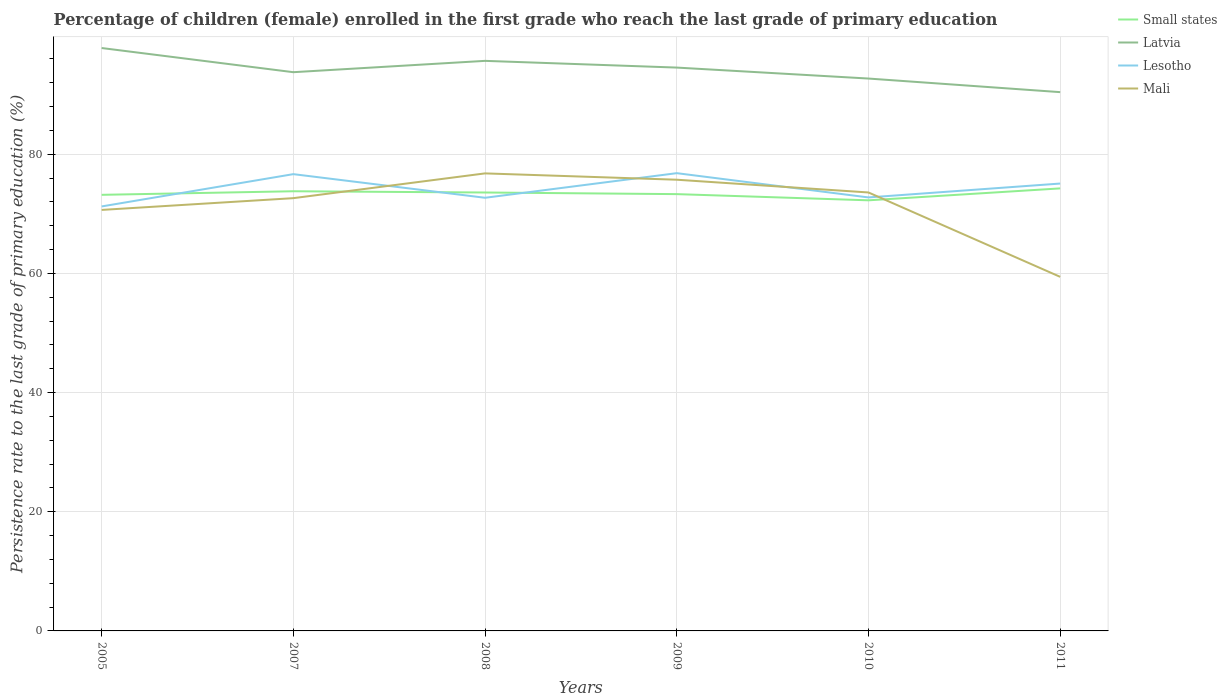Is the number of lines equal to the number of legend labels?
Provide a short and direct response. Yes. Across all years, what is the maximum persistence rate of children in Lesotho?
Provide a succinct answer. 71.23. In which year was the persistence rate of children in Latvia maximum?
Your answer should be compact. 2011. What is the total persistence rate of children in Small states in the graph?
Ensure brevity in your answer.  0.21. What is the difference between the highest and the second highest persistence rate of children in Lesotho?
Offer a very short reply. 5.58. How many years are there in the graph?
Offer a terse response. 6. Does the graph contain grids?
Offer a terse response. Yes. Where does the legend appear in the graph?
Offer a terse response. Top right. How many legend labels are there?
Your answer should be very brief. 4. What is the title of the graph?
Keep it short and to the point. Percentage of children (female) enrolled in the first grade who reach the last grade of primary education. Does "Europe(developing only)" appear as one of the legend labels in the graph?
Your response must be concise. No. What is the label or title of the Y-axis?
Your response must be concise. Persistence rate to the last grade of primary education (%). What is the Persistence rate to the last grade of primary education (%) of Small states in 2005?
Offer a very short reply. 73.18. What is the Persistence rate to the last grade of primary education (%) of Latvia in 2005?
Offer a terse response. 97.82. What is the Persistence rate to the last grade of primary education (%) of Lesotho in 2005?
Your response must be concise. 71.23. What is the Persistence rate to the last grade of primary education (%) of Mali in 2005?
Your answer should be compact. 70.65. What is the Persistence rate to the last grade of primary education (%) of Small states in 2007?
Your answer should be compact. 73.78. What is the Persistence rate to the last grade of primary education (%) of Latvia in 2007?
Your answer should be compact. 93.76. What is the Persistence rate to the last grade of primary education (%) of Lesotho in 2007?
Your answer should be compact. 76.65. What is the Persistence rate to the last grade of primary education (%) in Mali in 2007?
Offer a terse response. 72.62. What is the Persistence rate to the last grade of primary education (%) of Small states in 2008?
Your answer should be very brief. 73.57. What is the Persistence rate to the last grade of primary education (%) in Latvia in 2008?
Offer a very short reply. 95.66. What is the Persistence rate to the last grade of primary education (%) in Lesotho in 2008?
Your response must be concise. 72.69. What is the Persistence rate to the last grade of primary education (%) of Mali in 2008?
Your response must be concise. 76.78. What is the Persistence rate to the last grade of primary education (%) of Small states in 2009?
Your answer should be compact. 73.3. What is the Persistence rate to the last grade of primary education (%) of Latvia in 2009?
Make the answer very short. 94.54. What is the Persistence rate to the last grade of primary education (%) of Lesotho in 2009?
Give a very brief answer. 76.82. What is the Persistence rate to the last grade of primary education (%) of Mali in 2009?
Offer a very short reply. 75.72. What is the Persistence rate to the last grade of primary education (%) of Small states in 2010?
Offer a terse response. 72.26. What is the Persistence rate to the last grade of primary education (%) of Latvia in 2010?
Make the answer very short. 92.7. What is the Persistence rate to the last grade of primary education (%) of Lesotho in 2010?
Offer a terse response. 72.75. What is the Persistence rate to the last grade of primary education (%) of Mali in 2010?
Your answer should be very brief. 73.58. What is the Persistence rate to the last grade of primary education (%) of Small states in 2011?
Give a very brief answer. 74.26. What is the Persistence rate to the last grade of primary education (%) in Latvia in 2011?
Offer a terse response. 90.41. What is the Persistence rate to the last grade of primary education (%) of Lesotho in 2011?
Provide a short and direct response. 75.07. What is the Persistence rate to the last grade of primary education (%) in Mali in 2011?
Provide a short and direct response. 59.42. Across all years, what is the maximum Persistence rate to the last grade of primary education (%) of Small states?
Offer a very short reply. 74.26. Across all years, what is the maximum Persistence rate to the last grade of primary education (%) in Latvia?
Your response must be concise. 97.82. Across all years, what is the maximum Persistence rate to the last grade of primary education (%) in Lesotho?
Ensure brevity in your answer.  76.82. Across all years, what is the maximum Persistence rate to the last grade of primary education (%) in Mali?
Your answer should be compact. 76.78. Across all years, what is the minimum Persistence rate to the last grade of primary education (%) in Small states?
Give a very brief answer. 72.26. Across all years, what is the minimum Persistence rate to the last grade of primary education (%) of Latvia?
Provide a short and direct response. 90.41. Across all years, what is the minimum Persistence rate to the last grade of primary education (%) in Lesotho?
Offer a terse response. 71.23. Across all years, what is the minimum Persistence rate to the last grade of primary education (%) in Mali?
Provide a short and direct response. 59.42. What is the total Persistence rate to the last grade of primary education (%) in Small states in the graph?
Offer a terse response. 440.36. What is the total Persistence rate to the last grade of primary education (%) in Latvia in the graph?
Ensure brevity in your answer.  564.89. What is the total Persistence rate to the last grade of primary education (%) in Lesotho in the graph?
Provide a succinct answer. 445.21. What is the total Persistence rate to the last grade of primary education (%) in Mali in the graph?
Offer a very short reply. 428.77. What is the difference between the Persistence rate to the last grade of primary education (%) in Small states in 2005 and that in 2007?
Provide a succinct answer. -0.6. What is the difference between the Persistence rate to the last grade of primary education (%) of Latvia in 2005 and that in 2007?
Offer a terse response. 4.06. What is the difference between the Persistence rate to the last grade of primary education (%) in Lesotho in 2005 and that in 2007?
Offer a very short reply. -5.42. What is the difference between the Persistence rate to the last grade of primary education (%) in Mali in 2005 and that in 2007?
Your response must be concise. -1.97. What is the difference between the Persistence rate to the last grade of primary education (%) of Small states in 2005 and that in 2008?
Offer a very short reply. -0.39. What is the difference between the Persistence rate to the last grade of primary education (%) of Latvia in 2005 and that in 2008?
Provide a succinct answer. 2.15. What is the difference between the Persistence rate to the last grade of primary education (%) of Lesotho in 2005 and that in 2008?
Offer a terse response. -1.45. What is the difference between the Persistence rate to the last grade of primary education (%) in Mali in 2005 and that in 2008?
Your answer should be compact. -6.13. What is the difference between the Persistence rate to the last grade of primary education (%) of Small states in 2005 and that in 2009?
Make the answer very short. -0.12. What is the difference between the Persistence rate to the last grade of primary education (%) in Latvia in 2005 and that in 2009?
Keep it short and to the point. 3.28. What is the difference between the Persistence rate to the last grade of primary education (%) of Lesotho in 2005 and that in 2009?
Your answer should be compact. -5.58. What is the difference between the Persistence rate to the last grade of primary education (%) in Mali in 2005 and that in 2009?
Your response must be concise. -5.07. What is the difference between the Persistence rate to the last grade of primary education (%) in Small states in 2005 and that in 2010?
Offer a terse response. 0.92. What is the difference between the Persistence rate to the last grade of primary education (%) of Latvia in 2005 and that in 2010?
Make the answer very short. 5.12. What is the difference between the Persistence rate to the last grade of primary education (%) of Lesotho in 2005 and that in 2010?
Make the answer very short. -1.51. What is the difference between the Persistence rate to the last grade of primary education (%) in Mali in 2005 and that in 2010?
Offer a very short reply. -2.93. What is the difference between the Persistence rate to the last grade of primary education (%) of Small states in 2005 and that in 2011?
Your response must be concise. -1.08. What is the difference between the Persistence rate to the last grade of primary education (%) in Latvia in 2005 and that in 2011?
Offer a terse response. 7.4. What is the difference between the Persistence rate to the last grade of primary education (%) of Lesotho in 2005 and that in 2011?
Your response must be concise. -3.84. What is the difference between the Persistence rate to the last grade of primary education (%) in Mali in 2005 and that in 2011?
Give a very brief answer. 11.23. What is the difference between the Persistence rate to the last grade of primary education (%) of Small states in 2007 and that in 2008?
Ensure brevity in your answer.  0.21. What is the difference between the Persistence rate to the last grade of primary education (%) in Latvia in 2007 and that in 2008?
Your answer should be very brief. -1.9. What is the difference between the Persistence rate to the last grade of primary education (%) in Lesotho in 2007 and that in 2008?
Provide a short and direct response. 3.97. What is the difference between the Persistence rate to the last grade of primary education (%) of Mali in 2007 and that in 2008?
Make the answer very short. -4.16. What is the difference between the Persistence rate to the last grade of primary education (%) in Small states in 2007 and that in 2009?
Provide a short and direct response. 0.48. What is the difference between the Persistence rate to the last grade of primary education (%) in Latvia in 2007 and that in 2009?
Your response must be concise. -0.77. What is the difference between the Persistence rate to the last grade of primary education (%) of Lesotho in 2007 and that in 2009?
Make the answer very short. -0.16. What is the difference between the Persistence rate to the last grade of primary education (%) in Mali in 2007 and that in 2009?
Provide a short and direct response. -3.09. What is the difference between the Persistence rate to the last grade of primary education (%) of Small states in 2007 and that in 2010?
Offer a terse response. 1.52. What is the difference between the Persistence rate to the last grade of primary education (%) in Latvia in 2007 and that in 2010?
Your response must be concise. 1.07. What is the difference between the Persistence rate to the last grade of primary education (%) in Lesotho in 2007 and that in 2010?
Your answer should be compact. 3.91. What is the difference between the Persistence rate to the last grade of primary education (%) in Mali in 2007 and that in 2010?
Offer a very short reply. -0.95. What is the difference between the Persistence rate to the last grade of primary education (%) in Small states in 2007 and that in 2011?
Your answer should be very brief. -0.48. What is the difference between the Persistence rate to the last grade of primary education (%) in Latvia in 2007 and that in 2011?
Make the answer very short. 3.35. What is the difference between the Persistence rate to the last grade of primary education (%) in Lesotho in 2007 and that in 2011?
Offer a terse response. 1.58. What is the difference between the Persistence rate to the last grade of primary education (%) in Mali in 2007 and that in 2011?
Offer a very short reply. 13.21. What is the difference between the Persistence rate to the last grade of primary education (%) of Small states in 2008 and that in 2009?
Your answer should be compact. 0.27. What is the difference between the Persistence rate to the last grade of primary education (%) of Latvia in 2008 and that in 2009?
Your response must be concise. 1.13. What is the difference between the Persistence rate to the last grade of primary education (%) in Lesotho in 2008 and that in 2009?
Make the answer very short. -4.13. What is the difference between the Persistence rate to the last grade of primary education (%) in Mali in 2008 and that in 2009?
Offer a terse response. 1.06. What is the difference between the Persistence rate to the last grade of primary education (%) of Small states in 2008 and that in 2010?
Your answer should be very brief. 1.31. What is the difference between the Persistence rate to the last grade of primary education (%) in Latvia in 2008 and that in 2010?
Offer a terse response. 2.97. What is the difference between the Persistence rate to the last grade of primary education (%) in Lesotho in 2008 and that in 2010?
Your answer should be compact. -0.06. What is the difference between the Persistence rate to the last grade of primary education (%) of Mali in 2008 and that in 2010?
Keep it short and to the point. 3.2. What is the difference between the Persistence rate to the last grade of primary education (%) in Small states in 2008 and that in 2011?
Provide a succinct answer. -0.69. What is the difference between the Persistence rate to the last grade of primary education (%) in Latvia in 2008 and that in 2011?
Offer a terse response. 5.25. What is the difference between the Persistence rate to the last grade of primary education (%) in Lesotho in 2008 and that in 2011?
Keep it short and to the point. -2.39. What is the difference between the Persistence rate to the last grade of primary education (%) in Mali in 2008 and that in 2011?
Give a very brief answer. 17.36. What is the difference between the Persistence rate to the last grade of primary education (%) of Small states in 2009 and that in 2010?
Ensure brevity in your answer.  1.04. What is the difference between the Persistence rate to the last grade of primary education (%) in Latvia in 2009 and that in 2010?
Give a very brief answer. 1.84. What is the difference between the Persistence rate to the last grade of primary education (%) of Lesotho in 2009 and that in 2010?
Keep it short and to the point. 4.07. What is the difference between the Persistence rate to the last grade of primary education (%) in Mali in 2009 and that in 2010?
Ensure brevity in your answer.  2.14. What is the difference between the Persistence rate to the last grade of primary education (%) of Small states in 2009 and that in 2011?
Your answer should be compact. -0.96. What is the difference between the Persistence rate to the last grade of primary education (%) of Latvia in 2009 and that in 2011?
Keep it short and to the point. 4.12. What is the difference between the Persistence rate to the last grade of primary education (%) in Lesotho in 2009 and that in 2011?
Your response must be concise. 1.74. What is the difference between the Persistence rate to the last grade of primary education (%) in Mali in 2009 and that in 2011?
Make the answer very short. 16.3. What is the difference between the Persistence rate to the last grade of primary education (%) in Small states in 2010 and that in 2011?
Your answer should be very brief. -2. What is the difference between the Persistence rate to the last grade of primary education (%) in Latvia in 2010 and that in 2011?
Give a very brief answer. 2.28. What is the difference between the Persistence rate to the last grade of primary education (%) in Lesotho in 2010 and that in 2011?
Make the answer very short. -2.33. What is the difference between the Persistence rate to the last grade of primary education (%) in Mali in 2010 and that in 2011?
Make the answer very short. 14.16. What is the difference between the Persistence rate to the last grade of primary education (%) in Small states in 2005 and the Persistence rate to the last grade of primary education (%) in Latvia in 2007?
Your answer should be very brief. -20.58. What is the difference between the Persistence rate to the last grade of primary education (%) in Small states in 2005 and the Persistence rate to the last grade of primary education (%) in Lesotho in 2007?
Your answer should be very brief. -3.47. What is the difference between the Persistence rate to the last grade of primary education (%) in Small states in 2005 and the Persistence rate to the last grade of primary education (%) in Mali in 2007?
Your response must be concise. 0.56. What is the difference between the Persistence rate to the last grade of primary education (%) in Latvia in 2005 and the Persistence rate to the last grade of primary education (%) in Lesotho in 2007?
Provide a succinct answer. 21.17. What is the difference between the Persistence rate to the last grade of primary education (%) of Latvia in 2005 and the Persistence rate to the last grade of primary education (%) of Mali in 2007?
Your response must be concise. 25.2. What is the difference between the Persistence rate to the last grade of primary education (%) of Lesotho in 2005 and the Persistence rate to the last grade of primary education (%) of Mali in 2007?
Provide a succinct answer. -1.39. What is the difference between the Persistence rate to the last grade of primary education (%) in Small states in 2005 and the Persistence rate to the last grade of primary education (%) in Latvia in 2008?
Provide a short and direct response. -22.48. What is the difference between the Persistence rate to the last grade of primary education (%) of Small states in 2005 and the Persistence rate to the last grade of primary education (%) of Lesotho in 2008?
Keep it short and to the point. 0.49. What is the difference between the Persistence rate to the last grade of primary education (%) in Small states in 2005 and the Persistence rate to the last grade of primary education (%) in Mali in 2008?
Make the answer very short. -3.6. What is the difference between the Persistence rate to the last grade of primary education (%) of Latvia in 2005 and the Persistence rate to the last grade of primary education (%) of Lesotho in 2008?
Keep it short and to the point. 25.13. What is the difference between the Persistence rate to the last grade of primary education (%) of Latvia in 2005 and the Persistence rate to the last grade of primary education (%) of Mali in 2008?
Provide a succinct answer. 21.04. What is the difference between the Persistence rate to the last grade of primary education (%) in Lesotho in 2005 and the Persistence rate to the last grade of primary education (%) in Mali in 2008?
Your answer should be very brief. -5.55. What is the difference between the Persistence rate to the last grade of primary education (%) in Small states in 2005 and the Persistence rate to the last grade of primary education (%) in Latvia in 2009?
Your answer should be very brief. -21.35. What is the difference between the Persistence rate to the last grade of primary education (%) in Small states in 2005 and the Persistence rate to the last grade of primary education (%) in Lesotho in 2009?
Give a very brief answer. -3.63. What is the difference between the Persistence rate to the last grade of primary education (%) in Small states in 2005 and the Persistence rate to the last grade of primary education (%) in Mali in 2009?
Ensure brevity in your answer.  -2.54. What is the difference between the Persistence rate to the last grade of primary education (%) of Latvia in 2005 and the Persistence rate to the last grade of primary education (%) of Lesotho in 2009?
Give a very brief answer. 21. What is the difference between the Persistence rate to the last grade of primary education (%) in Latvia in 2005 and the Persistence rate to the last grade of primary education (%) in Mali in 2009?
Provide a short and direct response. 22.1. What is the difference between the Persistence rate to the last grade of primary education (%) in Lesotho in 2005 and the Persistence rate to the last grade of primary education (%) in Mali in 2009?
Keep it short and to the point. -4.48. What is the difference between the Persistence rate to the last grade of primary education (%) of Small states in 2005 and the Persistence rate to the last grade of primary education (%) of Latvia in 2010?
Provide a short and direct response. -19.51. What is the difference between the Persistence rate to the last grade of primary education (%) of Small states in 2005 and the Persistence rate to the last grade of primary education (%) of Lesotho in 2010?
Keep it short and to the point. 0.44. What is the difference between the Persistence rate to the last grade of primary education (%) in Small states in 2005 and the Persistence rate to the last grade of primary education (%) in Mali in 2010?
Provide a short and direct response. -0.4. What is the difference between the Persistence rate to the last grade of primary education (%) of Latvia in 2005 and the Persistence rate to the last grade of primary education (%) of Lesotho in 2010?
Provide a short and direct response. 25.07. What is the difference between the Persistence rate to the last grade of primary education (%) of Latvia in 2005 and the Persistence rate to the last grade of primary education (%) of Mali in 2010?
Give a very brief answer. 24.24. What is the difference between the Persistence rate to the last grade of primary education (%) of Lesotho in 2005 and the Persistence rate to the last grade of primary education (%) of Mali in 2010?
Offer a very short reply. -2.34. What is the difference between the Persistence rate to the last grade of primary education (%) of Small states in 2005 and the Persistence rate to the last grade of primary education (%) of Latvia in 2011?
Offer a very short reply. -17.23. What is the difference between the Persistence rate to the last grade of primary education (%) of Small states in 2005 and the Persistence rate to the last grade of primary education (%) of Lesotho in 2011?
Your response must be concise. -1.89. What is the difference between the Persistence rate to the last grade of primary education (%) in Small states in 2005 and the Persistence rate to the last grade of primary education (%) in Mali in 2011?
Your answer should be very brief. 13.76. What is the difference between the Persistence rate to the last grade of primary education (%) of Latvia in 2005 and the Persistence rate to the last grade of primary education (%) of Lesotho in 2011?
Offer a very short reply. 22.74. What is the difference between the Persistence rate to the last grade of primary education (%) of Latvia in 2005 and the Persistence rate to the last grade of primary education (%) of Mali in 2011?
Provide a succinct answer. 38.4. What is the difference between the Persistence rate to the last grade of primary education (%) in Lesotho in 2005 and the Persistence rate to the last grade of primary education (%) in Mali in 2011?
Give a very brief answer. 11.82. What is the difference between the Persistence rate to the last grade of primary education (%) of Small states in 2007 and the Persistence rate to the last grade of primary education (%) of Latvia in 2008?
Give a very brief answer. -21.88. What is the difference between the Persistence rate to the last grade of primary education (%) of Small states in 2007 and the Persistence rate to the last grade of primary education (%) of Lesotho in 2008?
Make the answer very short. 1.1. What is the difference between the Persistence rate to the last grade of primary education (%) in Small states in 2007 and the Persistence rate to the last grade of primary education (%) in Mali in 2008?
Your answer should be compact. -3. What is the difference between the Persistence rate to the last grade of primary education (%) of Latvia in 2007 and the Persistence rate to the last grade of primary education (%) of Lesotho in 2008?
Your answer should be compact. 21.07. What is the difference between the Persistence rate to the last grade of primary education (%) of Latvia in 2007 and the Persistence rate to the last grade of primary education (%) of Mali in 2008?
Ensure brevity in your answer.  16.98. What is the difference between the Persistence rate to the last grade of primary education (%) in Lesotho in 2007 and the Persistence rate to the last grade of primary education (%) in Mali in 2008?
Provide a short and direct response. -0.13. What is the difference between the Persistence rate to the last grade of primary education (%) in Small states in 2007 and the Persistence rate to the last grade of primary education (%) in Latvia in 2009?
Your response must be concise. -20.75. What is the difference between the Persistence rate to the last grade of primary education (%) in Small states in 2007 and the Persistence rate to the last grade of primary education (%) in Lesotho in 2009?
Your answer should be very brief. -3.03. What is the difference between the Persistence rate to the last grade of primary education (%) of Small states in 2007 and the Persistence rate to the last grade of primary education (%) of Mali in 2009?
Offer a terse response. -1.93. What is the difference between the Persistence rate to the last grade of primary education (%) in Latvia in 2007 and the Persistence rate to the last grade of primary education (%) in Lesotho in 2009?
Your answer should be very brief. 16.95. What is the difference between the Persistence rate to the last grade of primary education (%) in Latvia in 2007 and the Persistence rate to the last grade of primary education (%) in Mali in 2009?
Provide a short and direct response. 18.04. What is the difference between the Persistence rate to the last grade of primary education (%) in Lesotho in 2007 and the Persistence rate to the last grade of primary education (%) in Mali in 2009?
Ensure brevity in your answer.  0.94. What is the difference between the Persistence rate to the last grade of primary education (%) in Small states in 2007 and the Persistence rate to the last grade of primary education (%) in Latvia in 2010?
Offer a terse response. -18.91. What is the difference between the Persistence rate to the last grade of primary education (%) in Small states in 2007 and the Persistence rate to the last grade of primary education (%) in Lesotho in 2010?
Provide a succinct answer. 1.04. What is the difference between the Persistence rate to the last grade of primary education (%) of Small states in 2007 and the Persistence rate to the last grade of primary education (%) of Mali in 2010?
Give a very brief answer. 0.21. What is the difference between the Persistence rate to the last grade of primary education (%) in Latvia in 2007 and the Persistence rate to the last grade of primary education (%) in Lesotho in 2010?
Offer a terse response. 21.02. What is the difference between the Persistence rate to the last grade of primary education (%) in Latvia in 2007 and the Persistence rate to the last grade of primary education (%) in Mali in 2010?
Offer a terse response. 20.18. What is the difference between the Persistence rate to the last grade of primary education (%) of Lesotho in 2007 and the Persistence rate to the last grade of primary education (%) of Mali in 2010?
Ensure brevity in your answer.  3.08. What is the difference between the Persistence rate to the last grade of primary education (%) of Small states in 2007 and the Persistence rate to the last grade of primary education (%) of Latvia in 2011?
Keep it short and to the point. -16.63. What is the difference between the Persistence rate to the last grade of primary education (%) of Small states in 2007 and the Persistence rate to the last grade of primary education (%) of Lesotho in 2011?
Make the answer very short. -1.29. What is the difference between the Persistence rate to the last grade of primary education (%) in Small states in 2007 and the Persistence rate to the last grade of primary education (%) in Mali in 2011?
Provide a short and direct response. 14.36. What is the difference between the Persistence rate to the last grade of primary education (%) in Latvia in 2007 and the Persistence rate to the last grade of primary education (%) in Lesotho in 2011?
Provide a short and direct response. 18.69. What is the difference between the Persistence rate to the last grade of primary education (%) of Latvia in 2007 and the Persistence rate to the last grade of primary education (%) of Mali in 2011?
Provide a succinct answer. 34.34. What is the difference between the Persistence rate to the last grade of primary education (%) of Lesotho in 2007 and the Persistence rate to the last grade of primary education (%) of Mali in 2011?
Offer a very short reply. 17.23. What is the difference between the Persistence rate to the last grade of primary education (%) of Small states in 2008 and the Persistence rate to the last grade of primary education (%) of Latvia in 2009?
Offer a very short reply. -20.96. What is the difference between the Persistence rate to the last grade of primary education (%) of Small states in 2008 and the Persistence rate to the last grade of primary education (%) of Lesotho in 2009?
Ensure brevity in your answer.  -3.24. What is the difference between the Persistence rate to the last grade of primary education (%) of Small states in 2008 and the Persistence rate to the last grade of primary education (%) of Mali in 2009?
Provide a short and direct response. -2.14. What is the difference between the Persistence rate to the last grade of primary education (%) of Latvia in 2008 and the Persistence rate to the last grade of primary education (%) of Lesotho in 2009?
Your response must be concise. 18.85. What is the difference between the Persistence rate to the last grade of primary education (%) in Latvia in 2008 and the Persistence rate to the last grade of primary education (%) in Mali in 2009?
Offer a very short reply. 19.95. What is the difference between the Persistence rate to the last grade of primary education (%) of Lesotho in 2008 and the Persistence rate to the last grade of primary education (%) of Mali in 2009?
Ensure brevity in your answer.  -3.03. What is the difference between the Persistence rate to the last grade of primary education (%) in Small states in 2008 and the Persistence rate to the last grade of primary education (%) in Latvia in 2010?
Offer a terse response. -19.12. What is the difference between the Persistence rate to the last grade of primary education (%) of Small states in 2008 and the Persistence rate to the last grade of primary education (%) of Lesotho in 2010?
Your response must be concise. 0.83. What is the difference between the Persistence rate to the last grade of primary education (%) in Small states in 2008 and the Persistence rate to the last grade of primary education (%) in Mali in 2010?
Provide a succinct answer. -0. What is the difference between the Persistence rate to the last grade of primary education (%) in Latvia in 2008 and the Persistence rate to the last grade of primary education (%) in Lesotho in 2010?
Your answer should be compact. 22.92. What is the difference between the Persistence rate to the last grade of primary education (%) of Latvia in 2008 and the Persistence rate to the last grade of primary education (%) of Mali in 2010?
Keep it short and to the point. 22.09. What is the difference between the Persistence rate to the last grade of primary education (%) of Lesotho in 2008 and the Persistence rate to the last grade of primary education (%) of Mali in 2010?
Your answer should be compact. -0.89. What is the difference between the Persistence rate to the last grade of primary education (%) of Small states in 2008 and the Persistence rate to the last grade of primary education (%) of Latvia in 2011?
Provide a short and direct response. -16.84. What is the difference between the Persistence rate to the last grade of primary education (%) in Small states in 2008 and the Persistence rate to the last grade of primary education (%) in Lesotho in 2011?
Ensure brevity in your answer.  -1.5. What is the difference between the Persistence rate to the last grade of primary education (%) of Small states in 2008 and the Persistence rate to the last grade of primary education (%) of Mali in 2011?
Keep it short and to the point. 14.15. What is the difference between the Persistence rate to the last grade of primary education (%) in Latvia in 2008 and the Persistence rate to the last grade of primary education (%) in Lesotho in 2011?
Your answer should be very brief. 20.59. What is the difference between the Persistence rate to the last grade of primary education (%) in Latvia in 2008 and the Persistence rate to the last grade of primary education (%) in Mali in 2011?
Offer a terse response. 36.25. What is the difference between the Persistence rate to the last grade of primary education (%) in Lesotho in 2008 and the Persistence rate to the last grade of primary education (%) in Mali in 2011?
Keep it short and to the point. 13.27. What is the difference between the Persistence rate to the last grade of primary education (%) of Small states in 2009 and the Persistence rate to the last grade of primary education (%) of Latvia in 2010?
Make the answer very short. -19.4. What is the difference between the Persistence rate to the last grade of primary education (%) of Small states in 2009 and the Persistence rate to the last grade of primary education (%) of Lesotho in 2010?
Ensure brevity in your answer.  0.55. What is the difference between the Persistence rate to the last grade of primary education (%) in Small states in 2009 and the Persistence rate to the last grade of primary education (%) in Mali in 2010?
Your answer should be very brief. -0.28. What is the difference between the Persistence rate to the last grade of primary education (%) in Latvia in 2009 and the Persistence rate to the last grade of primary education (%) in Lesotho in 2010?
Offer a very short reply. 21.79. What is the difference between the Persistence rate to the last grade of primary education (%) of Latvia in 2009 and the Persistence rate to the last grade of primary education (%) of Mali in 2010?
Provide a short and direct response. 20.96. What is the difference between the Persistence rate to the last grade of primary education (%) in Lesotho in 2009 and the Persistence rate to the last grade of primary education (%) in Mali in 2010?
Give a very brief answer. 3.24. What is the difference between the Persistence rate to the last grade of primary education (%) in Small states in 2009 and the Persistence rate to the last grade of primary education (%) in Latvia in 2011?
Provide a succinct answer. -17.11. What is the difference between the Persistence rate to the last grade of primary education (%) in Small states in 2009 and the Persistence rate to the last grade of primary education (%) in Lesotho in 2011?
Offer a very short reply. -1.77. What is the difference between the Persistence rate to the last grade of primary education (%) in Small states in 2009 and the Persistence rate to the last grade of primary education (%) in Mali in 2011?
Provide a succinct answer. 13.88. What is the difference between the Persistence rate to the last grade of primary education (%) of Latvia in 2009 and the Persistence rate to the last grade of primary education (%) of Lesotho in 2011?
Your response must be concise. 19.46. What is the difference between the Persistence rate to the last grade of primary education (%) of Latvia in 2009 and the Persistence rate to the last grade of primary education (%) of Mali in 2011?
Ensure brevity in your answer.  35.12. What is the difference between the Persistence rate to the last grade of primary education (%) in Lesotho in 2009 and the Persistence rate to the last grade of primary education (%) in Mali in 2011?
Give a very brief answer. 17.4. What is the difference between the Persistence rate to the last grade of primary education (%) in Small states in 2010 and the Persistence rate to the last grade of primary education (%) in Latvia in 2011?
Make the answer very short. -18.15. What is the difference between the Persistence rate to the last grade of primary education (%) in Small states in 2010 and the Persistence rate to the last grade of primary education (%) in Lesotho in 2011?
Your answer should be very brief. -2.81. What is the difference between the Persistence rate to the last grade of primary education (%) of Small states in 2010 and the Persistence rate to the last grade of primary education (%) of Mali in 2011?
Ensure brevity in your answer.  12.84. What is the difference between the Persistence rate to the last grade of primary education (%) in Latvia in 2010 and the Persistence rate to the last grade of primary education (%) in Lesotho in 2011?
Give a very brief answer. 17.62. What is the difference between the Persistence rate to the last grade of primary education (%) in Latvia in 2010 and the Persistence rate to the last grade of primary education (%) in Mali in 2011?
Offer a terse response. 33.28. What is the difference between the Persistence rate to the last grade of primary education (%) of Lesotho in 2010 and the Persistence rate to the last grade of primary education (%) of Mali in 2011?
Offer a terse response. 13.33. What is the average Persistence rate to the last grade of primary education (%) in Small states per year?
Provide a short and direct response. 73.39. What is the average Persistence rate to the last grade of primary education (%) in Latvia per year?
Provide a succinct answer. 94.15. What is the average Persistence rate to the last grade of primary education (%) in Lesotho per year?
Provide a short and direct response. 74.2. What is the average Persistence rate to the last grade of primary education (%) of Mali per year?
Make the answer very short. 71.46. In the year 2005, what is the difference between the Persistence rate to the last grade of primary education (%) of Small states and Persistence rate to the last grade of primary education (%) of Latvia?
Make the answer very short. -24.64. In the year 2005, what is the difference between the Persistence rate to the last grade of primary education (%) of Small states and Persistence rate to the last grade of primary education (%) of Lesotho?
Your response must be concise. 1.95. In the year 2005, what is the difference between the Persistence rate to the last grade of primary education (%) in Small states and Persistence rate to the last grade of primary education (%) in Mali?
Offer a very short reply. 2.53. In the year 2005, what is the difference between the Persistence rate to the last grade of primary education (%) in Latvia and Persistence rate to the last grade of primary education (%) in Lesotho?
Your answer should be very brief. 26.59. In the year 2005, what is the difference between the Persistence rate to the last grade of primary education (%) of Latvia and Persistence rate to the last grade of primary education (%) of Mali?
Offer a terse response. 27.17. In the year 2005, what is the difference between the Persistence rate to the last grade of primary education (%) in Lesotho and Persistence rate to the last grade of primary education (%) in Mali?
Your response must be concise. 0.58. In the year 2007, what is the difference between the Persistence rate to the last grade of primary education (%) in Small states and Persistence rate to the last grade of primary education (%) in Latvia?
Make the answer very short. -19.98. In the year 2007, what is the difference between the Persistence rate to the last grade of primary education (%) of Small states and Persistence rate to the last grade of primary education (%) of Lesotho?
Offer a very short reply. -2.87. In the year 2007, what is the difference between the Persistence rate to the last grade of primary education (%) of Small states and Persistence rate to the last grade of primary education (%) of Mali?
Your answer should be compact. 1.16. In the year 2007, what is the difference between the Persistence rate to the last grade of primary education (%) in Latvia and Persistence rate to the last grade of primary education (%) in Lesotho?
Give a very brief answer. 17.11. In the year 2007, what is the difference between the Persistence rate to the last grade of primary education (%) of Latvia and Persistence rate to the last grade of primary education (%) of Mali?
Your response must be concise. 21.14. In the year 2007, what is the difference between the Persistence rate to the last grade of primary education (%) in Lesotho and Persistence rate to the last grade of primary education (%) in Mali?
Your answer should be very brief. 4.03. In the year 2008, what is the difference between the Persistence rate to the last grade of primary education (%) of Small states and Persistence rate to the last grade of primary education (%) of Latvia?
Give a very brief answer. -22.09. In the year 2008, what is the difference between the Persistence rate to the last grade of primary education (%) in Small states and Persistence rate to the last grade of primary education (%) in Lesotho?
Provide a short and direct response. 0.89. In the year 2008, what is the difference between the Persistence rate to the last grade of primary education (%) in Small states and Persistence rate to the last grade of primary education (%) in Mali?
Your answer should be compact. -3.21. In the year 2008, what is the difference between the Persistence rate to the last grade of primary education (%) of Latvia and Persistence rate to the last grade of primary education (%) of Lesotho?
Offer a very short reply. 22.98. In the year 2008, what is the difference between the Persistence rate to the last grade of primary education (%) in Latvia and Persistence rate to the last grade of primary education (%) in Mali?
Keep it short and to the point. 18.88. In the year 2008, what is the difference between the Persistence rate to the last grade of primary education (%) in Lesotho and Persistence rate to the last grade of primary education (%) in Mali?
Provide a short and direct response. -4.09. In the year 2009, what is the difference between the Persistence rate to the last grade of primary education (%) in Small states and Persistence rate to the last grade of primary education (%) in Latvia?
Provide a succinct answer. -21.24. In the year 2009, what is the difference between the Persistence rate to the last grade of primary education (%) of Small states and Persistence rate to the last grade of primary education (%) of Lesotho?
Make the answer very short. -3.52. In the year 2009, what is the difference between the Persistence rate to the last grade of primary education (%) in Small states and Persistence rate to the last grade of primary education (%) in Mali?
Offer a terse response. -2.42. In the year 2009, what is the difference between the Persistence rate to the last grade of primary education (%) in Latvia and Persistence rate to the last grade of primary education (%) in Lesotho?
Your answer should be compact. 17.72. In the year 2009, what is the difference between the Persistence rate to the last grade of primary education (%) in Latvia and Persistence rate to the last grade of primary education (%) in Mali?
Ensure brevity in your answer.  18.82. In the year 2009, what is the difference between the Persistence rate to the last grade of primary education (%) of Lesotho and Persistence rate to the last grade of primary education (%) of Mali?
Your answer should be compact. 1.1. In the year 2010, what is the difference between the Persistence rate to the last grade of primary education (%) of Small states and Persistence rate to the last grade of primary education (%) of Latvia?
Keep it short and to the point. -20.43. In the year 2010, what is the difference between the Persistence rate to the last grade of primary education (%) of Small states and Persistence rate to the last grade of primary education (%) of Lesotho?
Provide a succinct answer. -0.48. In the year 2010, what is the difference between the Persistence rate to the last grade of primary education (%) of Small states and Persistence rate to the last grade of primary education (%) of Mali?
Make the answer very short. -1.32. In the year 2010, what is the difference between the Persistence rate to the last grade of primary education (%) in Latvia and Persistence rate to the last grade of primary education (%) in Lesotho?
Keep it short and to the point. 19.95. In the year 2010, what is the difference between the Persistence rate to the last grade of primary education (%) in Latvia and Persistence rate to the last grade of primary education (%) in Mali?
Ensure brevity in your answer.  19.12. In the year 2010, what is the difference between the Persistence rate to the last grade of primary education (%) in Lesotho and Persistence rate to the last grade of primary education (%) in Mali?
Provide a succinct answer. -0.83. In the year 2011, what is the difference between the Persistence rate to the last grade of primary education (%) of Small states and Persistence rate to the last grade of primary education (%) of Latvia?
Your response must be concise. -16.15. In the year 2011, what is the difference between the Persistence rate to the last grade of primary education (%) in Small states and Persistence rate to the last grade of primary education (%) in Lesotho?
Provide a succinct answer. -0.81. In the year 2011, what is the difference between the Persistence rate to the last grade of primary education (%) in Small states and Persistence rate to the last grade of primary education (%) in Mali?
Make the answer very short. 14.84. In the year 2011, what is the difference between the Persistence rate to the last grade of primary education (%) of Latvia and Persistence rate to the last grade of primary education (%) of Lesotho?
Offer a terse response. 15.34. In the year 2011, what is the difference between the Persistence rate to the last grade of primary education (%) in Latvia and Persistence rate to the last grade of primary education (%) in Mali?
Your response must be concise. 31. In the year 2011, what is the difference between the Persistence rate to the last grade of primary education (%) in Lesotho and Persistence rate to the last grade of primary education (%) in Mali?
Make the answer very short. 15.66. What is the ratio of the Persistence rate to the last grade of primary education (%) in Small states in 2005 to that in 2007?
Keep it short and to the point. 0.99. What is the ratio of the Persistence rate to the last grade of primary education (%) of Latvia in 2005 to that in 2007?
Provide a short and direct response. 1.04. What is the ratio of the Persistence rate to the last grade of primary education (%) in Lesotho in 2005 to that in 2007?
Provide a succinct answer. 0.93. What is the ratio of the Persistence rate to the last grade of primary education (%) of Mali in 2005 to that in 2007?
Your response must be concise. 0.97. What is the ratio of the Persistence rate to the last grade of primary education (%) of Latvia in 2005 to that in 2008?
Ensure brevity in your answer.  1.02. What is the ratio of the Persistence rate to the last grade of primary education (%) in Lesotho in 2005 to that in 2008?
Provide a short and direct response. 0.98. What is the ratio of the Persistence rate to the last grade of primary education (%) in Mali in 2005 to that in 2008?
Ensure brevity in your answer.  0.92. What is the ratio of the Persistence rate to the last grade of primary education (%) of Small states in 2005 to that in 2009?
Keep it short and to the point. 1. What is the ratio of the Persistence rate to the last grade of primary education (%) of Latvia in 2005 to that in 2009?
Your answer should be very brief. 1.03. What is the ratio of the Persistence rate to the last grade of primary education (%) of Lesotho in 2005 to that in 2009?
Your answer should be compact. 0.93. What is the ratio of the Persistence rate to the last grade of primary education (%) in Mali in 2005 to that in 2009?
Provide a short and direct response. 0.93. What is the ratio of the Persistence rate to the last grade of primary education (%) of Small states in 2005 to that in 2010?
Provide a short and direct response. 1.01. What is the ratio of the Persistence rate to the last grade of primary education (%) of Latvia in 2005 to that in 2010?
Give a very brief answer. 1.06. What is the ratio of the Persistence rate to the last grade of primary education (%) in Lesotho in 2005 to that in 2010?
Offer a very short reply. 0.98. What is the ratio of the Persistence rate to the last grade of primary education (%) of Mali in 2005 to that in 2010?
Keep it short and to the point. 0.96. What is the ratio of the Persistence rate to the last grade of primary education (%) in Small states in 2005 to that in 2011?
Provide a succinct answer. 0.99. What is the ratio of the Persistence rate to the last grade of primary education (%) of Latvia in 2005 to that in 2011?
Provide a short and direct response. 1.08. What is the ratio of the Persistence rate to the last grade of primary education (%) of Lesotho in 2005 to that in 2011?
Give a very brief answer. 0.95. What is the ratio of the Persistence rate to the last grade of primary education (%) of Mali in 2005 to that in 2011?
Give a very brief answer. 1.19. What is the ratio of the Persistence rate to the last grade of primary education (%) in Latvia in 2007 to that in 2008?
Your response must be concise. 0.98. What is the ratio of the Persistence rate to the last grade of primary education (%) in Lesotho in 2007 to that in 2008?
Keep it short and to the point. 1.05. What is the ratio of the Persistence rate to the last grade of primary education (%) of Mali in 2007 to that in 2008?
Offer a terse response. 0.95. What is the ratio of the Persistence rate to the last grade of primary education (%) of Small states in 2007 to that in 2009?
Offer a very short reply. 1.01. What is the ratio of the Persistence rate to the last grade of primary education (%) in Mali in 2007 to that in 2009?
Your answer should be very brief. 0.96. What is the ratio of the Persistence rate to the last grade of primary education (%) of Latvia in 2007 to that in 2010?
Provide a short and direct response. 1.01. What is the ratio of the Persistence rate to the last grade of primary education (%) of Lesotho in 2007 to that in 2010?
Provide a short and direct response. 1.05. What is the ratio of the Persistence rate to the last grade of primary education (%) in Small states in 2007 to that in 2011?
Your answer should be very brief. 0.99. What is the ratio of the Persistence rate to the last grade of primary education (%) in Latvia in 2007 to that in 2011?
Your response must be concise. 1.04. What is the ratio of the Persistence rate to the last grade of primary education (%) in Mali in 2007 to that in 2011?
Keep it short and to the point. 1.22. What is the ratio of the Persistence rate to the last grade of primary education (%) in Small states in 2008 to that in 2009?
Keep it short and to the point. 1. What is the ratio of the Persistence rate to the last grade of primary education (%) in Latvia in 2008 to that in 2009?
Give a very brief answer. 1.01. What is the ratio of the Persistence rate to the last grade of primary education (%) in Lesotho in 2008 to that in 2009?
Your answer should be compact. 0.95. What is the ratio of the Persistence rate to the last grade of primary education (%) of Mali in 2008 to that in 2009?
Keep it short and to the point. 1.01. What is the ratio of the Persistence rate to the last grade of primary education (%) in Small states in 2008 to that in 2010?
Offer a very short reply. 1.02. What is the ratio of the Persistence rate to the last grade of primary education (%) in Latvia in 2008 to that in 2010?
Keep it short and to the point. 1.03. What is the ratio of the Persistence rate to the last grade of primary education (%) in Lesotho in 2008 to that in 2010?
Your answer should be very brief. 1. What is the ratio of the Persistence rate to the last grade of primary education (%) in Mali in 2008 to that in 2010?
Your response must be concise. 1.04. What is the ratio of the Persistence rate to the last grade of primary education (%) in Latvia in 2008 to that in 2011?
Your answer should be compact. 1.06. What is the ratio of the Persistence rate to the last grade of primary education (%) of Lesotho in 2008 to that in 2011?
Make the answer very short. 0.97. What is the ratio of the Persistence rate to the last grade of primary education (%) of Mali in 2008 to that in 2011?
Keep it short and to the point. 1.29. What is the ratio of the Persistence rate to the last grade of primary education (%) in Small states in 2009 to that in 2010?
Make the answer very short. 1.01. What is the ratio of the Persistence rate to the last grade of primary education (%) in Latvia in 2009 to that in 2010?
Provide a short and direct response. 1.02. What is the ratio of the Persistence rate to the last grade of primary education (%) in Lesotho in 2009 to that in 2010?
Offer a very short reply. 1.06. What is the ratio of the Persistence rate to the last grade of primary education (%) of Mali in 2009 to that in 2010?
Your response must be concise. 1.03. What is the ratio of the Persistence rate to the last grade of primary education (%) of Small states in 2009 to that in 2011?
Provide a short and direct response. 0.99. What is the ratio of the Persistence rate to the last grade of primary education (%) of Latvia in 2009 to that in 2011?
Your answer should be very brief. 1.05. What is the ratio of the Persistence rate to the last grade of primary education (%) in Lesotho in 2009 to that in 2011?
Your answer should be compact. 1.02. What is the ratio of the Persistence rate to the last grade of primary education (%) in Mali in 2009 to that in 2011?
Make the answer very short. 1.27. What is the ratio of the Persistence rate to the last grade of primary education (%) of Small states in 2010 to that in 2011?
Provide a short and direct response. 0.97. What is the ratio of the Persistence rate to the last grade of primary education (%) in Latvia in 2010 to that in 2011?
Keep it short and to the point. 1.03. What is the ratio of the Persistence rate to the last grade of primary education (%) in Lesotho in 2010 to that in 2011?
Provide a succinct answer. 0.97. What is the ratio of the Persistence rate to the last grade of primary education (%) in Mali in 2010 to that in 2011?
Your answer should be compact. 1.24. What is the difference between the highest and the second highest Persistence rate to the last grade of primary education (%) of Small states?
Provide a succinct answer. 0.48. What is the difference between the highest and the second highest Persistence rate to the last grade of primary education (%) in Latvia?
Provide a short and direct response. 2.15. What is the difference between the highest and the second highest Persistence rate to the last grade of primary education (%) of Lesotho?
Offer a terse response. 0.16. What is the difference between the highest and the second highest Persistence rate to the last grade of primary education (%) in Mali?
Your answer should be very brief. 1.06. What is the difference between the highest and the lowest Persistence rate to the last grade of primary education (%) in Small states?
Your response must be concise. 2. What is the difference between the highest and the lowest Persistence rate to the last grade of primary education (%) in Latvia?
Offer a terse response. 7.4. What is the difference between the highest and the lowest Persistence rate to the last grade of primary education (%) of Lesotho?
Provide a succinct answer. 5.58. What is the difference between the highest and the lowest Persistence rate to the last grade of primary education (%) of Mali?
Provide a short and direct response. 17.36. 